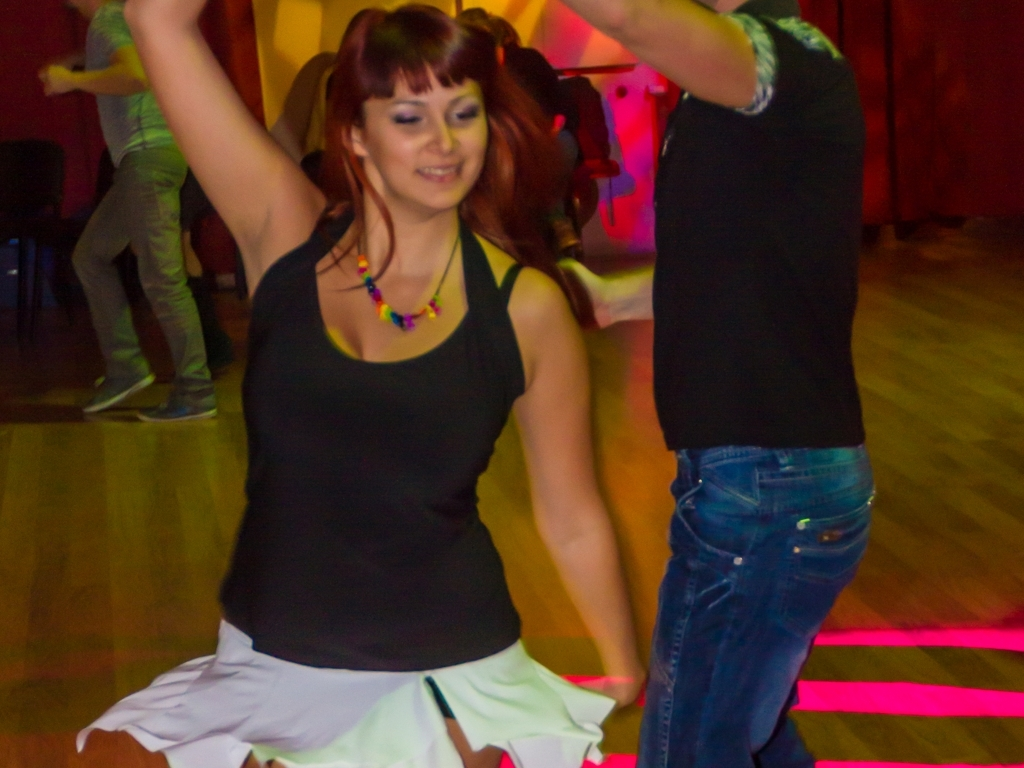What can be inferred about the event from this image? While details are limited, it's likely that this image captures a moment at a social dance gathering or class. The informal attire of the participants, the vibrant and varied colors in the background, and the dance posture all suggest an event focused on communal enjoyment of dance, rather than a formal competition or performance. 